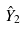Convert formula to latex. <formula><loc_0><loc_0><loc_500><loc_500>\hat { Y } _ { 2 }</formula> 